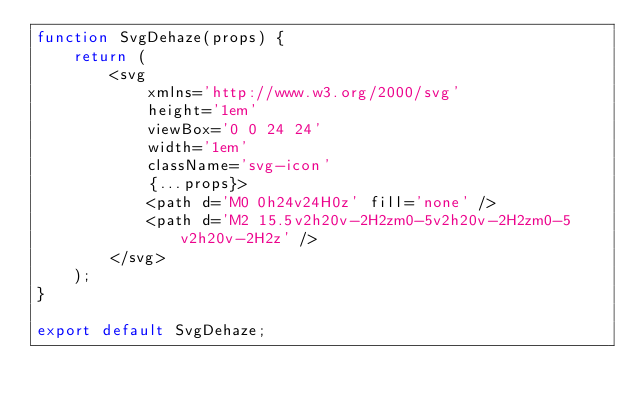<code> <loc_0><loc_0><loc_500><loc_500><_JavaScript_>function SvgDehaze(props) {
	return (
		<svg
			xmlns='http://www.w3.org/2000/svg'
			height='1em'
			viewBox='0 0 24 24'
			width='1em'
			className='svg-icon'
			{...props}>
			<path d='M0 0h24v24H0z' fill='none' />
			<path d='M2 15.5v2h20v-2H2zm0-5v2h20v-2H2zm0-5v2h20v-2H2z' />
		</svg>
	);
}

export default SvgDehaze;
</code> 